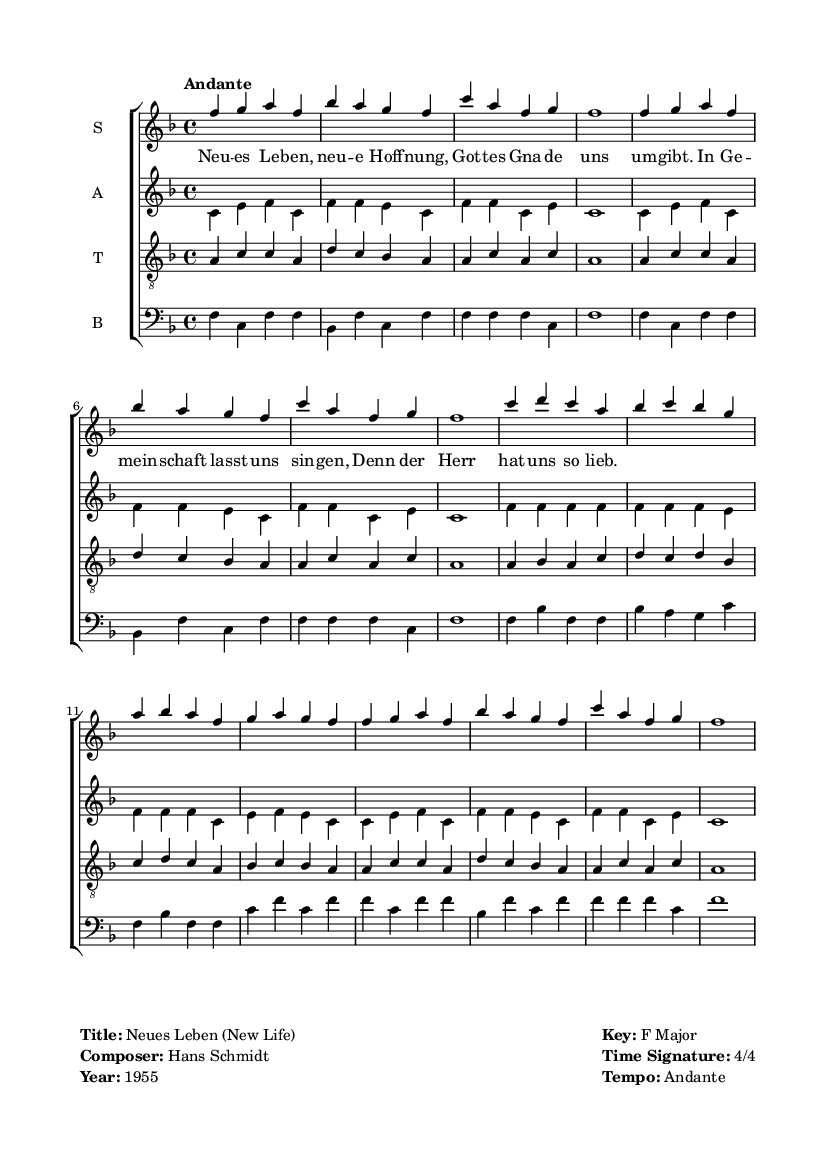What is the title of the piece? The title is prominently displayed at the top of the rendered sheet music, which specifies the piece as "Neues Leben".
Answer: Neues Leben Who is the composer of this piece? The composer is indicated alongside the title in the markup section of the code, showing it as "Hans Schmidt".
Answer: Hans Schmidt What is the key signature of this music? The key signature is denoted at the beginning of the musical staff. For this piece, it is identified as F major, which has one flat (B flat).
Answer: F major What is the time signature? The time signature is observed next to the clef and indicates the number of beats in each measure. Here, it is shown as 4/4, meaning there are four beats per measure.
Answer: 4/4 What is the tempo marking for this piece? The tempo marking is indicated by the word "Andante", which suggests a moderate walking pace for the performance of the music.
Answer: Andante Which voice part has the highest melody line? In choral works, the soprano typically carries the highest melodic line. Upon examining the score, the soprano voice is written in the treble clef and is placed at the top of the staff, which confirms its position as the highest.
Answer: Soprano What musical function does the text set to the music serve in a religious context? The lyrics are often integrative to church services, portraying themes of hope, community, and divine love. This piece, specifically highlighting "New Life," indicates its role in liturgical settings where congregants are prompted to reflect on renewal and grace.
Answer: Liturgical worship 